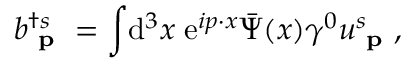<formula> <loc_0><loc_0><loc_500><loc_500>b _ { p } ^ { \dagger s } = \int \, d ^ { 3 } x \, e ^ { i p \cdot x } { \bar { \Psi } } ( x ) \gamma ^ { 0 } u _ { p } ^ { s } ,</formula> 